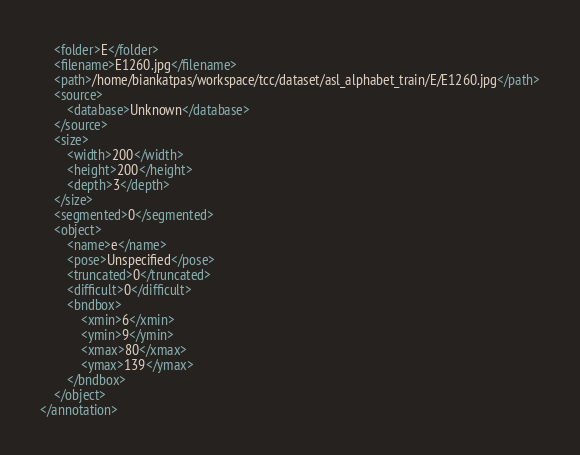<code> <loc_0><loc_0><loc_500><loc_500><_XML_>	<folder>E</folder>
	<filename>E1260.jpg</filename>
	<path>/home/biankatpas/workspace/tcc/dataset/asl_alphabet_train/E/E1260.jpg</path>
	<source>
		<database>Unknown</database>
	</source>
	<size>
		<width>200</width>
		<height>200</height>
		<depth>3</depth>
	</size>
	<segmented>0</segmented>
	<object>
		<name>e</name>
		<pose>Unspecified</pose>
		<truncated>0</truncated>
		<difficult>0</difficult>
		<bndbox>
			<xmin>6</xmin>
			<ymin>9</ymin>
			<xmax>80</xmax>
			<ymax>139</ymax>
		</bndbox>
	</object>
</annotation>
</code> 